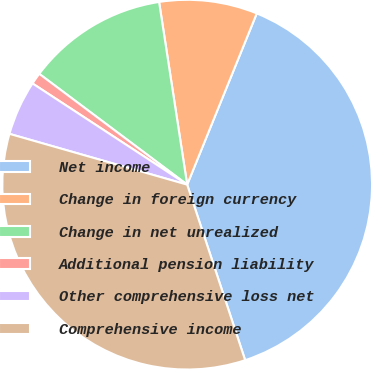Convert chart to OTSL. <chart><loc_0><loc_0><loc_500><loc_500><pie_chart><fcel>Net income<fcel>Change in foreign currency<fcel>Change in net unrealized<fcel>Additional pension liability<fcel>Other comprehensive loss net<fcel>Comprehensive income<nl><fcel>38.78%<fcel>8.57%<fcel>12.34%<fcel>1.01%<fcel>4.79%<fcel>34.51%<nl></chart> 